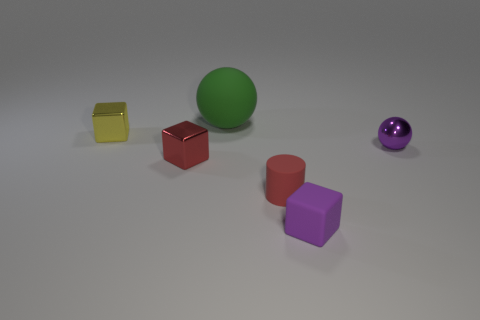Add 3 big matte spheres. How many objects exist? 9 Subtract all spheres. How many objects are left? 4 Subtract all big matte balls. Subtract all matte things. How many objects are left? 2 Add 1 red metallic cubes. How many red metallic cubes are left? 2 Add 5 big purple cylinders. How many big purple cylinders exist? 5 Subtract 0 cyan cylinders. How many objects are left? 6 